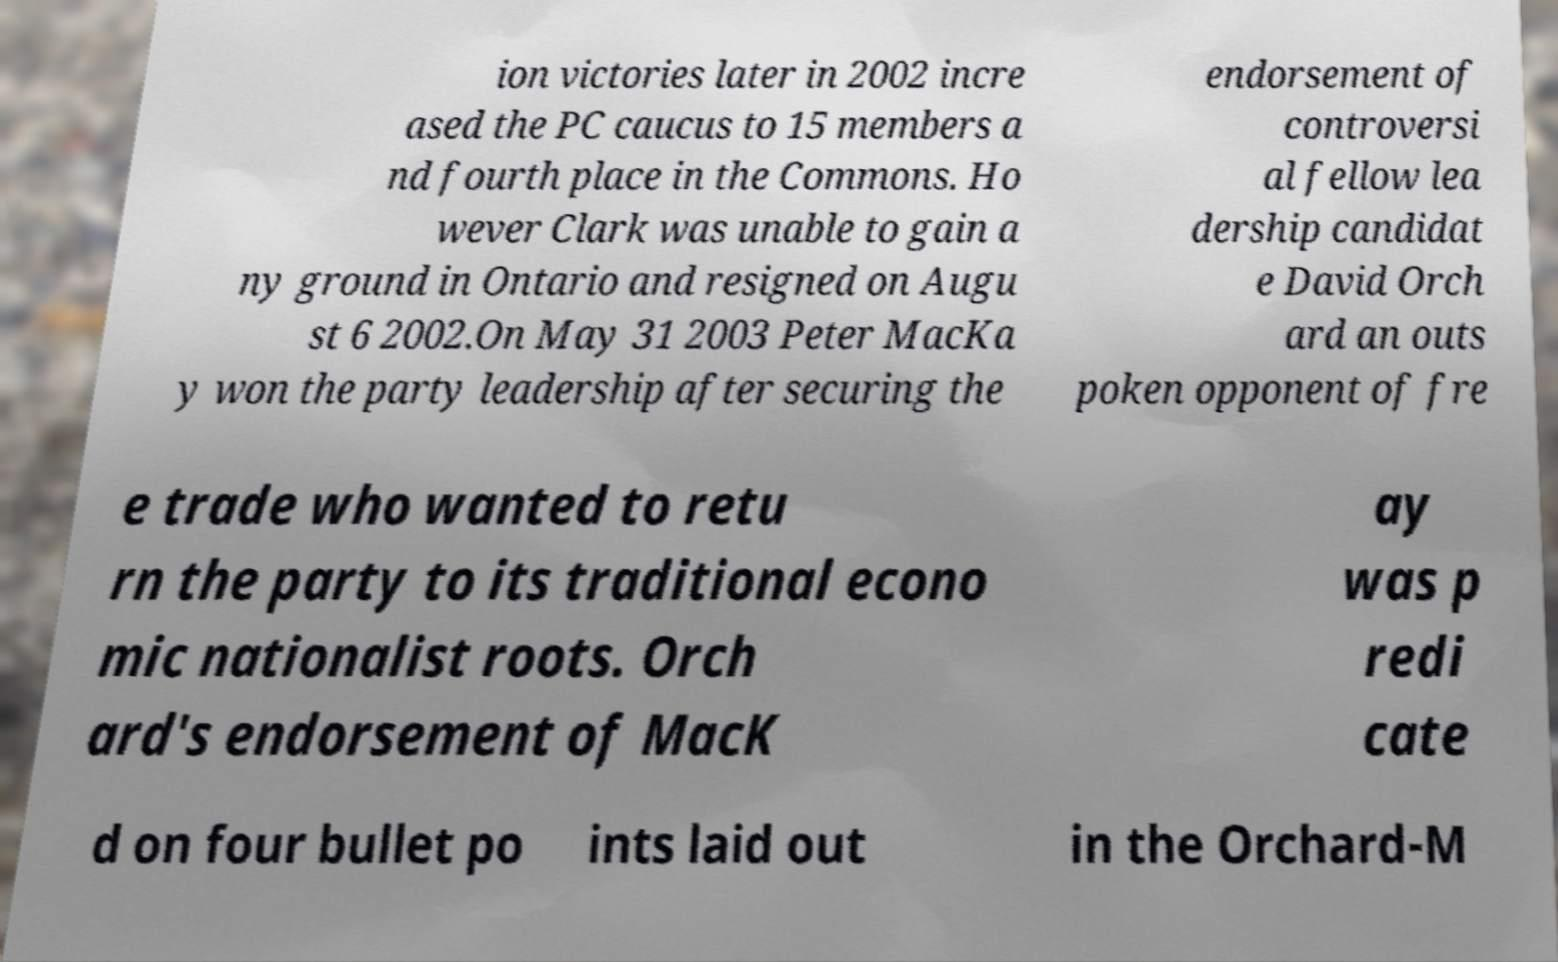Can you accurately transcribe the text from the provided image for me? ion victories later in 2002 incre ased the PC caucus to 15 members a nd fourth place in the Commons. Ho wever Clark was unable to gain a ny ground in Ontario and resigned on Augu st 6 2002.On May 31 2003 Peter MacKa y won the party leadership after securing the endorsement of controversi al fellow lea dership candidat e David Orch ard an outs poken opponent of fre e trade who wanted to retu rn the party to its traditional econo mic nationalist roots. Orch ard's endorsement of MacK ay was p redi cate d on four bullet po ints laid out in the Orchard-M 